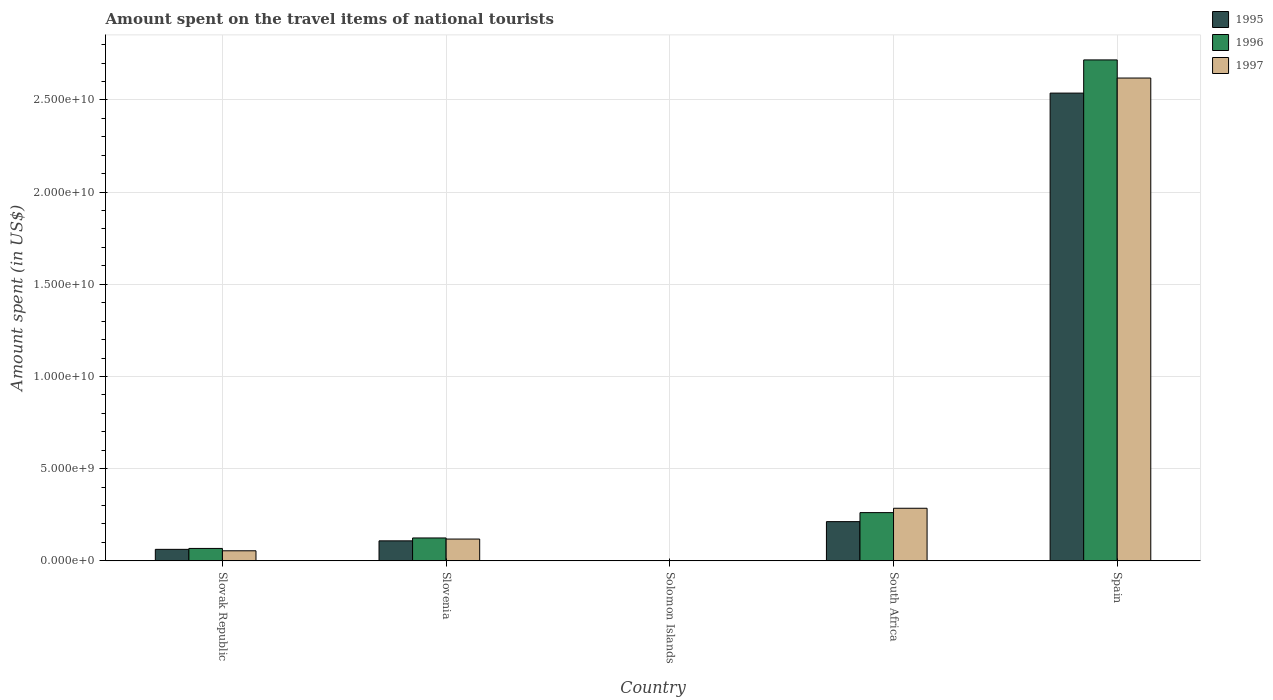How many different coloured bars are there?
Offer a terse response. 3. Are the number of bars per tick equal to the number of legend labels?
Make the answer very short. Yes. How many bars are there on the 5th tick from the right?
Provide a succinct answer. 3. What is the label of the 1st group of bars from the left?
Keep it short and to the point. Slovak Republic. What is the amount spent on the travel items of national tourists in 1995 in South Africa?
Your answer should be very brief. 2.13e+09. Across all countries, what is the maximum amount spent on the travel items of national tourists in 1997?
Give a very brief answer. 2.62e+1. Across all countries, what is the minimum amount spent on the travel items of national tourists in 1995?
Offer a terse response. 1.57e+07. In which country was the amount spent on the travel items of national tourists in 1997 minimum?
Keep it short and to the point. Solomon Islands. What is the total amount spent on the travel items of national tourists in 1996 in the graph?
Ensure brevity in your answer.  3.17e+1. What is the difference between the amount spent on the travel items of national tourists in 1997 in Slovak Republic and that in Solomon Islands?
Make the answer very short. 5.38e+08. What is the difference between the amount spent on the travel items of national tourists in 1996 in Slovenia and the amount spent on the travel items of national tourists in 1997 in Slovak Republic?
Your response must be concise. 6.95e+08. What is the average amount spent on the travel items of national tourists in 1995 per country?
Provide a short and direct response. 5.84e+09. What is the difference between the amount spent on the travel items of national tourists of/in 1997 and amount spent on the travel items of national tourists of/in 1996 in Solomon Islands?
Make the answer very short. -6.80e+06. In how many countries, is the amount spent on the travel items of national tourists in 1995 greater than 6000000000 US$?
Keep it short and to the point. 1. What is the ratio of the amount spent on the travel items of national tourists in 1997 in Slovak Republic to that in Solomon Islands?
Offer a terse response. 76.76. Is the amount spent on the travel items of national tourists in 1996 in Solomon Islands less than that in Spain?
Provide a succinct answer. Yes. What is the difference between the highest and the second highest amount spent on the travel items of national tourists in 1997?
Your answer should be very brief. 2.50e+1. What is the difference between the highest and the lowest amount spent on the travel items of national tourists in 1997?
Give a very brief answer. 2.62e+1. In how many countries, is the amount spent on the travel items of national tourists in 1995 greater than the average amount spent on the travel items of national tourists in 1995 taken over all countries?
Your answer should be compact. 1. What does the 2nd bar from the left in Solomon Islands represents?
Your answer should be compact. 1996. How many countries are there in the graph?
Provide a short and direct response. 5. Does the graph contain grids?
Ensure brevity in your answer.  Yes. Where does the legend appear in the graph?
Offer a very short reply. Top right. What is the title of the graph?
Ensure brevity in your answer.  Amount spent on the travel items of national tourists. What is the label or title of the Y-axis?
Your answer should be compact. Amount spent (in US$). What is the Amount spent (in US$) in 1995 in Slovak Republic?
Provide a short and direct response. 6.23e+08. What is the Amount spent (in US$) in 1996 in Slovak Republic?
Give a very brief answer. 6.73e+08. What is the Amount spent (in US$) in 1997 in Slovak Republic?
Provide a short and direct response. 5.45e+08. What is the Amount spent (in US$) in 1995 in Slovenia?
Offer a very short reply. 1.08e+09. What is the Amount spent (in US$) in 1996 in Slovenia?
Give a very brief answer. 1.24e+09. What is the Amount spent (in US$) of 1997 in Slovenia?
Your answer should be very brief. 1.18e+09. What is the Amount spent (in US$) in 1995 in Solomon Islands?
Offer a very short reply. 1.57e+07. What is the Amount spent (in US$) in 1996 in Solomon Islands?
Offer a terse response. 1.39e+07. What is the Amount spent (in US$) in 1997 in Solomon Islands?
Offer a very short reply. 7.10e+06. What is the Amount spent (in US$) in 1995 in South Africa?
Make the answer very short. 2.13e+09. What is the Amount spent (in US$) of 1996 in South Africa?
Make the answer very short. 2.62e+09. What is the Amount spent (in US$) in 1997 in South Africa?
Give a very brief answer. 2.85e+09. What is the Amount spent (in US$) of 1995 in Spain?
Your response must be concise. 2.54e+1. What is the Amount spent (in US$) in 1996 in Spain?
Offer a terse response. 2.72e+1. What is the Amount spent (in US$) in 1997 in Spain?
Provide a succinct answer. 2.62e+1. Across all countries, what is the maximum Amount spent (in US$) in 1995?
Make the answer very short. 2.54e+1. Across all countries, what is the maximum Amount spent (in US$) of 1996?
Provide a succinct answer. 2.72e+1. Across all countries, what is the maximum Amount spent (in US$) in 1997?
Offer a very short reply. 2.62e+1. Across all countries, what is the minimum Amount spent (in US$) in 1995?
Your answer should be compact. 1.57e+07. Across all countries, what is the minimum Amount spent (in US$) in 1996?
Make the answer very short. 1.39e+07. Across all countries, what is the minimum Amount spent (in US$) of 1997?
Offer a terse response. 7.10e+06. What is the total Amount spent (in US$) in 1995 in the graph?
Your response must be concise. 2.92e+1. What is the total Amount spent (in US$) in 1996 in the graph?
Provide a short and direct response. 3.17e+1. What is the total Amount spent (in US$) of 1997 in the graph?
Your answer should be very brief. 3.08e+1. What is the difference between the Amount spent (in US$) in 1995 in Slovak Republic and that in Slovenia?
Ensure brevity in your answer.  -4.61e+08. What is the difference between the Amount spent (in US$) of 1996 in Slovak Republic and that in Slovenia?
Provide a succinct answer. -5.67e+08. What is the difference between the Amount spent (in US$) in 1997 in Slovak Republic and that in Slovenia?
Offer a very short reply. -6.36e+08. What is the difference between the Amount spent (in US$) of 1995 in Slovak Republic and that in Solomon Islands?
Make the answer very short. 6.07e+08. What is the difference between the Amount spent (in US$) of 1996 in Slovak Republic and that in Solomon Islands?
Provide a short and direct response. 6.59e+08. What is the difference between the Amount spent (in US$) in 1997 in Slovak Republic and that in Solomon Islands?
Your response must be concise. 5.38e+08. What is the difference between the Amount spent (in US$) in 1995 in Slovak Republic and that in South Africa?
Make the answer very short. -1.50e+09. What is the difference between the Amount spent (in US$) of 1996 in Slovak Republic and that in South Africa?
Your response must be concise. -1.94e+09. What is the difference between the Amount spent (in US$) in 1997 in Slovak Republic and that in South Africa?
Your answer should be compact. -2.31e+09. What is the difference between the Amount spent (in US$) of 1995 in Slovak Republic and that in Spain?
Offer a terse response. -2.47e+1. What is the difference between the Amount spent (in US$) in 1996 in Slovak Republic and that in Spain?
Offer a very short reply. -2.65e+1. What is the difference between the Amount spent (in US$) of 1997 in Slovak Republic and that in Spain?
Your answer should be very brief. -2.56e+1. What is the difference between the Amount spent (in US$) of 1995 in Slovenia and that in Solomon Islands?
Keep it short and to the point. 1.07e+09. What is the difference between the Amount spent (in US$) of 1996 in Slovenia and that in Solomon Islands?
Ensure brevity in your answer.  1.23e+09. What is the difference between the Amount spent (in US$) of 1997 in Slovenia and that in Solomon Islands?
Provide a short and direct response. 1.17e+09. What is the difference between the Amount spent (in US$) in 1995 in Slovenia and that in South Africa?
Provide a short and direct response. -1.04e+09. What is the difference between the Amount spent (in US$) in 1996 in Slovenia and that in South Africa?
Provide a short and direct response. -1.38e+09. What is the difference between the Amount spent (in US$) of 1997 in Slovenia and that in South Africa?
Offer a terse response. -1.67e+09. What is the difference between the Amount spent (in US$) in 1995 in Slovenia and that in Spain?
Give a very brief answer. -2.43e+1. What is the difference between the Amount spent (in US$) of 1996 in Slovenia and that in Spain?
Your answer should be compact. -2.59e+1. What is the difference between the Amount spent (in US$) in 1997 in Slovenia and that in Spain?
Ensure brevity in your answer.  -2.50e+1. What is the difference between the Amount spent (in US$) of 1995 in Solomon Islands and that in South Africa?
Provide a succinct answer. -2.11e+09. What is the difference between the Amount spent (in US$) of 1996 in Solomon Islands and that in South Africa?
Offer a very short reply. -2.60e+09. What is the difference between the Amount spent (in US$) of 1997 in Solomon Islands and that in South Africa?
Provide a succinct answer. -2.84e+09. What is the difference between the Amount spent (in US$) in 1995 in Solomon Islands and that in Spain?
Make the answer very short. -2.54e+1. What is the difference between the Amount spent (in US$) in 1996 in Solomon Islands and that in Spain?
Offer a terse response. -2.72e+1. What is the difference between the Amount spent (in US$) in 1997 in Solomon Islands and that in Spain?
Give a very brief answer. -2.62e+1. What is the difference between the Amount spent (in US$) in 1995 in South Africa and that in Spain?
Your answer should be very brief. -2.32e+1. What is the difference between the Amount spent (in US$) in 1996 in South Africa and that in Spain?
Provide a succinct answer. -2.46e+1. What is the difference between the Amount spent (in US$) of 1997 in South Africa and that in Spain?
Provide a short and direct response. -2.33e+1. What is the difference between the Amount spent (in US$) in 1995 in Slovak Republic and the Amount spent (in US$) in 1996 in Slovenia?
Your answer should be very brief. -6.17e+08. What is the difference between the Amount spent (in US$) of 1995 in Slovak Republic and the Amount spent (in US$) of 1997 in Slovenia?
Provide a succinct answer. -5.58e+08. What is the difference between the Amount spent (in US$) in 1996 in Slovak Republic and the Amount spent (in US$) in 1997 in Slovenia?
Offer a terse response. -5.08e+08. What is the difference between the Amount spent (in US$) in 1995 in Slovak Republic and the Amount spent (in US$) in 1996 in Solomon Islands?
Your answer should be very brief. 6.09e+08. What is the difference between the Amount spent (in US$) in 1995 in Slovak Republic and the Amount spent (in US$) in 1997 in Solomon Islands?
Your response must be concise. 6.16e+08. What is the difference between the Amount spent (in US$) of 1996 in Slovak Republic and the Amount spent (in US$) of 1997 in Solomon Islands?
Keep it short and to the point. 6.66e+08. What is the difference between the Amount spent (in US$) in 1995 in Slovak Republic and the Amount spent (in US$) in 1996 in South Africa?
Make the answer very short. -1.99e+09. What is the difference between the Amount spent (in US$) in 1995 in Slovak Republic and the Amount spent (in US$) in 1997 in South Africa?
Offer a very short reply. -2.23e+09. What is the difference between the Amount spent (in US$) of 1996 in Slovak Republic and the Amount spent (in US$) of 1997 in South Africa?
Give a very brief answer. -2.18e+09. What is the difference between the Amount spent (in US$) of 1995 in Slovak Republic and the Amount spent (in US$) of 1996 in Spain?
Offer a very short reply. -2.65e+1. What is the difference between the Amount spent (in US$) in 1995 in Slovak Republic and the Amount spent (in US$) in 1997 in Spain?
Provide a succinct answer. -2.56e+1. What is the difference between the Amount spent (in US$) in 1996 in Slovak Republic and the Amount spent (in US$) in 1997 in Spain?
Your response must be concise. -2.55e+1. What is the difference between the Amount spent (in US$) of 1995 in Slovenia and the Amount spent (in US$) of 1996 in Solomon Islands?
Keep it short and to the point. 1.07e+09. What is the difference between the Amount spent (in US$) in 1995 in Slovenia and the Amount spent (in US$) in 1997 in Solomon Islands?
Provide a succinct answer. 1.08e+09. What is the difference between the Amount spent (in US$) of 1996 in Slovenia and the Amount spent (in US$) of 1997 in Solomon Islands?
Provide a short and direct response. 1.23e+09. What is the difference between the Amount spent (in US$) of 1995 in Slovenia and the Amount spent (in US$) of 1996 in South Africa?
Your answer should be compact. -1.53e+09. What is the difference between the Amount spent (in US$) of 1995 in Slovenia and the Amount spent (in US$) of 1997 in South Africa?
Ensure brevity in your answer.  -1.77e+09. What is the difference between the Amount spent (in US$) of 1996 in Slovenia and the Amount spent (in US$) of 1997 in South Africa?
Provide a succinct answer. -1.61e+09. What is the difference between the Amount spent (in US$) of 1995 in Slovenia and the Amount spent (in US$) of 1996 in Spain?
Your answer should be compact. -2.61e+1. What is the difference between the Amount spent (in US$) in 1995 in Slovenia and the Amount spent (in US$) in 1997 in Spain?
Your answer should be compact. -2.51e+1. What is the difference between the Amount spent (in US$) of 1996 in Slovenia and the Amount spent (in US$) of 1997 in Spain?
Your answer should be very brief. -2.49e+1. What is the difference between the Amount spent (in US$) in 1995 in Solomon Islands and the Amount spent (in US$) in 1996 in South Africa?
Your answer should be compact. -2.60e+09. What is the difference between the Amount spent (in US$) in 1995 in Solomon Islands and the Amount spent (in US$) in 1997 in South Africa?
Your answer should be very brief. -2.84e+09. What is the difference between the Amount spent (in US$) in 1996 in Solomon Islands and the Amount spent (in US$) in 1997 in South Africa?
Provide a short and direct response. -2.84e+09. What is the difference between the Amount spent (in US$) of 1995 in Solomon Islands and the Amount spent (in US$) of 1996 in Spain?
Your answer should be very brief. -2.72e+1. What is the difference between the Amount spent (in US$) of 1995 in Solomon Islands and the Amount spent (in US$) of 1997 in Spain?
Make the answer very short. -2.62e+1. What is the difference between the Amount spent (in US$) in 1996 in Solomon Islands and the Amount spent (in US$) in 1997 in Spain?
Give a very brief answer. -2.62e+1. What is the difference between the Amount spent (in US$) of 1995 in South Africa and the Amount spent (in US$) of 1996 in Spain?
Your response must be concise. -2.50e+1. What is the difference between the Amount spent (in US$) in 1995 in South Africa and the Amount spent (in US$) in 1997 in Spain?
Ensure brevity in your answer.  -2.41e+1. What is the difference between the Amount spent (in US$) in 1996 in South Africa and the Amount spent (in US$) in 1997 in Spain?
Give a very brief answer. -2.36e+1. What is the average Amount spent (in US$) in 1995 per country?
Offer a very short reply. 5.84e+09. What is the average Amount spent (in US$) in 1996 per country?
Offer a very short reply. 6.34e+09. What is the average Amount spent (in US$) in 1997 per country?
Make the answer very short. 6.15e+09. What is the difference between the Amount spent (in US$) of 1995 and Amount spent (in US$) of 1996 in Slovak Republic?
Offer a terse response. -5.00e+07. What is the difference between the Amount spent (in US$) in 1995 and Amount spent (in US$) in 1997 in Slovak Republic?
Your answer should be very brief. 7.80e+07. What is the difference between the Amount spent (in US$) in 1996 and Amount spent (in US$) in 1997 in Slovak Republic?
Provide a short and direct response. 1.28e+08. What is the difference between the Amount spent (in US$) in 1995 and Amount spent (in US$) in 1996 in Slovenia?
Provide a short and direct response. -1.56e+08. What is the difference between the Amount spent (in US$) of 1995 and Amount spent (in US$) of 1997 in Slovenia?
Provide a short and direct response. -9.70e+07. What is the difference between the Amount spent (in US$) of 1996 and Amount spent (in US$) of 1997 in Slovenia?
Make the answer very short. 5.90e+07. What is the difference between the Amount spent (in US$) in 1995 and Amount spent (in US$) in 1996 in Solomon Islands?
Provide a succinct answer. 1.80e+06. What is the difference between the Amount spent (in US$) of 1995 and Amount spent (in US$) of 1997 in Solomon Islands?
Keep it short and to the point. 8.60e+06. What is the difference between the Amount spent (in US$) of 1996 and Amount spent (in US$) of 1997 in Solomon Islands?
Offer a terse response. 6.80e+06. What is the difference between the Amount spent (in US$) in 1995 and Amount spent (in US$) in 1996 in South Africa?
Ensure brevity in your answer.  -4.89e+08. What is the difference between the Amount spent (in US$) in 1995 and Amount spent (in US$) in 1997 in South Africa?
Ensure brevity in your answer.  -7.25e+08. What is the difference between the Amount spent (in US$) in 1996 and Amount spent (in US$) in 1997 in South Africa?
Keep it short and to the point. -2.36e+08. What is the difference between the Amount spent (in US$) of 1995 and Amount spent (in US$) of 1996 in Spain?
Ensure brevity in your answer.  -1.80e+09. What is the difference between the Amount spent (in US$) in 1995 and Amount spent (in US$) in 1997 in Spain?
Make the answer very short. -8.17e+08. What is the difference between the Amount spent (in US$) of 1996 and Amount spent (in US$) of 1997 in Spain?
Offer a very short reply. 9.83e+08. What is the ratio of the Amount spent (in US$) in 1995 in Slovak Republic to that in Slovenia?
Give a very brief answer. 0.57. What is the ratio of the Amount spent (in US$) in 1996 in Slovak Republic to that in Slovenia?
Your answer should be very brief. 0.54. What is the ratio of the Amount spent (in US$) in 1997 in Slovak Republic to that in Slovenia?
Provide a short and direct response. 0.46. What is the ratio of the Amount spent (in US$) in 1995 in Slovak Republic to that in Solomon Islands?
Your response must be concise. 39.68. What is the ratio of the Amount spent (in US$) of 1996 in Slovak Republic to that in Solomon Islands?
Provide a short and direct response. 48.42. What is the ratio of the Amount spent (in US$) of 1997 in Slovak Republic to that in Solomon Islands?
Keep it short and to the point. 76.76. What is the ratio of the Amount spent (in US$) in 1995 in Slovak Republic to that in South Africa?
Your answer should be compact. 0.29. What is the ratio of the Amount spent (in US$) in 1996 in Slovak Republic to that in South Africa?
Keep it short and to the point. 0.26. What is the ratio of the Amount spent (in US$) in 1997 in Slovak Republic to that in South Africa?
Offer a very short reply. 0.19. What is the ratio of the Amount spent (in US$) in 1995 in Slovak Republic to that in Spain?
Your answer should be compact. 0.02. What is the ratio of the Amount spent (in US$) in 1996 in Slovak Republic to that in Spain?
Your answer should be very brief. 0.02. What is the ratio of the Amount spent (in US$) in 1997 in Slovak Republic to that in Spain?
Keep it short and to the point. 0.02. What is the ratio of the Amount spent (in US$) of 1995 in Slovenia to that in Solomon Islands?
Ensure brevity in your answer.  69.04. What is the ratio of the Amount spent (in US$) in 1996 in Slovenia to that in Solomon Islands?
Provide a short and direct response. 89.21. What is the ratio of the Amount spent (in US$) in 1997 in Slovenia to that in Solomon Islands?
Provide a succinct answer. 166.34. What is the ratio of the Amount spent (in US$) in 1995 in Slovenia to that in South Africa?
Your answer should be compact. 0.51. What is the ratio of the Amount spent (in US$) in 1996 in Slovenia to that in South Africa?
Offer a terse response. 0.47. What is the ratio of the Amount spent (in US$) of 1997 in Slovenia to that in South Africa?
Your response must be concise. 0.41. What is the ratio of the Amount spent (in US$) in 1995 in Slovenia to that in Spain?
Keep it short and to the point. 0.04. What is the ratio of the Amount spent (in US$) of 1996 in Slovenia to that in Spain?
Offer a very short reply. 0.05. What is the ratio of the Amount spent (in US$) of 1997 in Slovenia to that in Spain?
Keep it short and to the point. 0.05. What is the ratio of the Amount spent (in US$) of 1995 in Solomon Islands to that in South Africa?
Give a very brief answer. 0.01. What is the ratio of the Amount spent (in US$) in 1996 in Solomon Islands to that in South Africa?
Your answer should be very brief. 0.01. What is the ratio of the Amount spent (in US$) of 1997 in Solomon Islands to that in South Africa?
Provide a succinct answer. 0. What is the ratio of the Amount spent (in US$) in 1995 in Solomon Islands to that in Spain?
Provide a succinct answer. 0. What is the ratio of the Amount spent (in US$) of 1997 in Solomon Islands to that in Spain?
Your answer should be compact. 0. What is the ratio of the Amount spent (in US$) of 1995 in South Africa to that in Spain?
Provide a short and direct response. 0.08. What is the ratio of the Amount spent (in US$) in 1996 in South Africa to that in Spain?
Offer a terse response. 0.1. What is the ratio of the Amount spent (in US$) of 1997 in South Africa to that in Spain?
Ensure brevity in your answer.  0.11. What is the difference between the highest and the second highest Amount spent (in US$) in 1995?
Provide a short and direct response. 2.32e+1. What is the difference between the highest and the second highest Amount spent (in US$) of 1996?
Provide a succinct answer. 2.46e+1. What is the difference between the highest and the second highest Amount spent (in US$) of 1997?
Make the answer very short. 2.33e+1. What is the difference between the highest and the lowest Amount spent (in US$) in 1995?
Provide a short and direct response. 2.54e+1. What is the difference between the highest and the lowest Amount spent (in US$) in 1996?
Offer a very short reply. 2.72e+1. What is the difference between the highest and the lowest Amount spent (in US$) in 1997?
Give a very brief answer. 2.62e+1. 